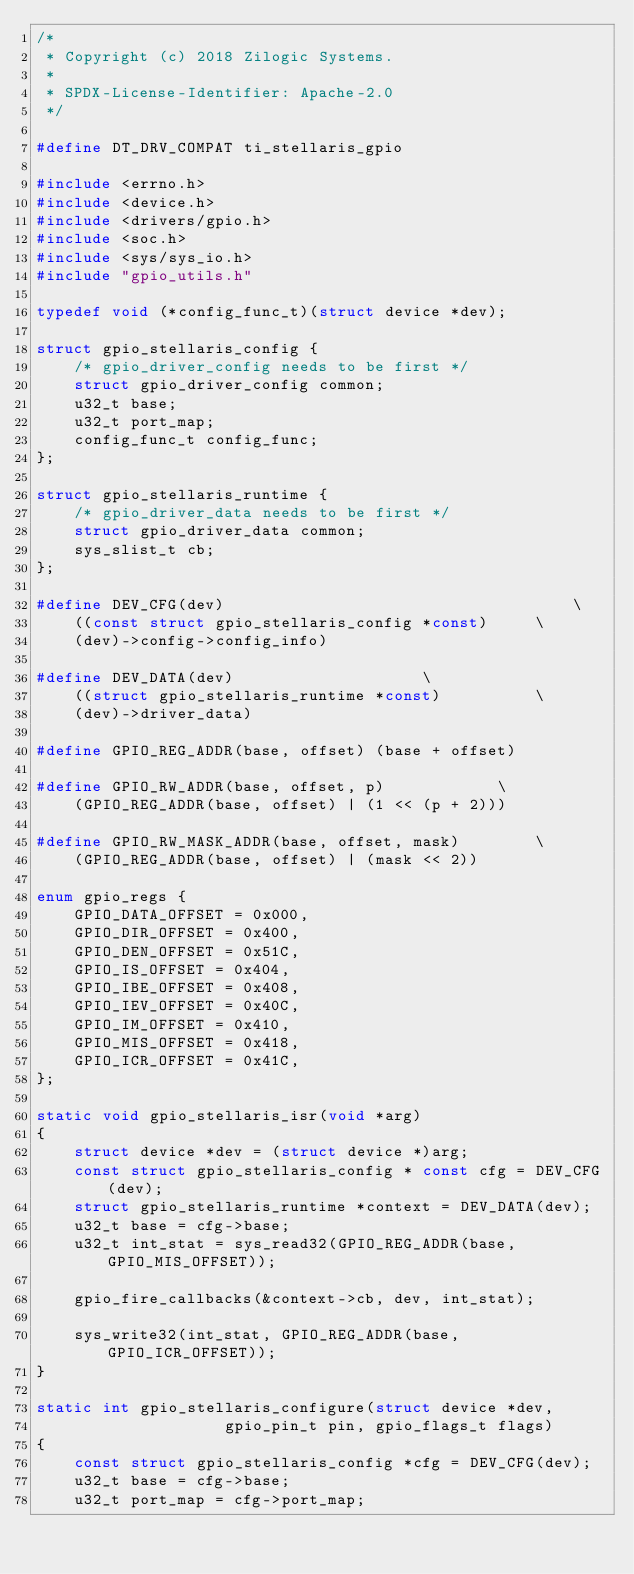<code> <loc_0><loc_0><loc_500><loc_500><_C_>/*
 * Copyright (c) 2018 Zilogic Systems.
 *
 * SPDX-License-Identifier: Apache-2.0
 */

#define DT_DRV_COMPAT ti_stellaris_gpio

#include <errno.h>
#include <device.h>
#include <drivers/gpio.h>
#include <soc.h>
#include <sys/sys_io.h>
#include "gpio_utils.h"

typedef void (*config_func_t)(struct device *dev);

struct gpio_stellaris_config {
	/* gpio_driver_config needs to be first */
	struct gpio_driver_config common;
	u32_t base;
	u32_t port_map;
	config_func_t config_func;
};

struct gpio_stellaris_runtime {
	/* gpio_driver_data needs to be first */
	struct gpio_driver_data common;
	sys_slist_t cb;
};

#define DEV_CFG(dev)                                     \
	((const struct gpio_stellaris_config *const)     \
	(dev)->config->config_info)

#define DEV_DATA(dev)					 \
	((struct gpio_stellaris_runtime *const)          \
	(dev)->driver_data)

#define GPIO_REG_ADDR(base, offset) (base + offset)

#define GPIO_RW_ADDR(base, offset, p)			 \
	(GPIO_REG_ADDR(base, offset) | (1 << (p + 2)))

#define GPIO_RW_MASK_ADDR(base, offset, mask)		 \
	(GPIO_REG_ADDR(base, offset) | (mask << 2))

enum gpio_regs {
	GPIO_DATA_OFFSET = 0x000,
	GPIO_DIR_OFFSET = 0x400,
	GPIO_DEN_OFFSET = 0x51C,
	GPIO_IS_OFFSET = 0x404,
	GPIO_IBE_OFFSET = 0x408,
	GPIO_IEV_OFFSET = 0x40C,
	GPIO_IM_OFFSET = 0x410,
	GPIO_MIS_OFFSET = 0x418,
	GPIO_ICR_OFFSET = 0x41C,
};

static void gpio_stellaris_isr(void *arg)
{
	struct device *dev = (struct device *)arg;
	const struct gpio_stellaris_config * const cfg = DEV_CFG(dev);
	struct gpio_stellaris_runtime *context = DEV_DATA(dev);
	u32_t base = cfg->base;
	u32_t int_stat = sys_read32(GPIO_REG_ADDR(base, GPIO_MIS_OFFSET));

	gpio_fire_callbacks(&context->cb, dev, int_stat);

	sys_write32(int_stat, GPIO_REG_ADDR(base, GPIO_ICR_OFFSET));
}

static int gpio_stellaris_configure(struct device *dev,
				    gpio_pin_t pin, gpio_flags_t flags)
{
	const struct gpio_stellaris_config *cfg = DEV_CFG(dev);
	u32_t base = cfg->base;
	u32_t port_map = cfg->port_map;
</code> 